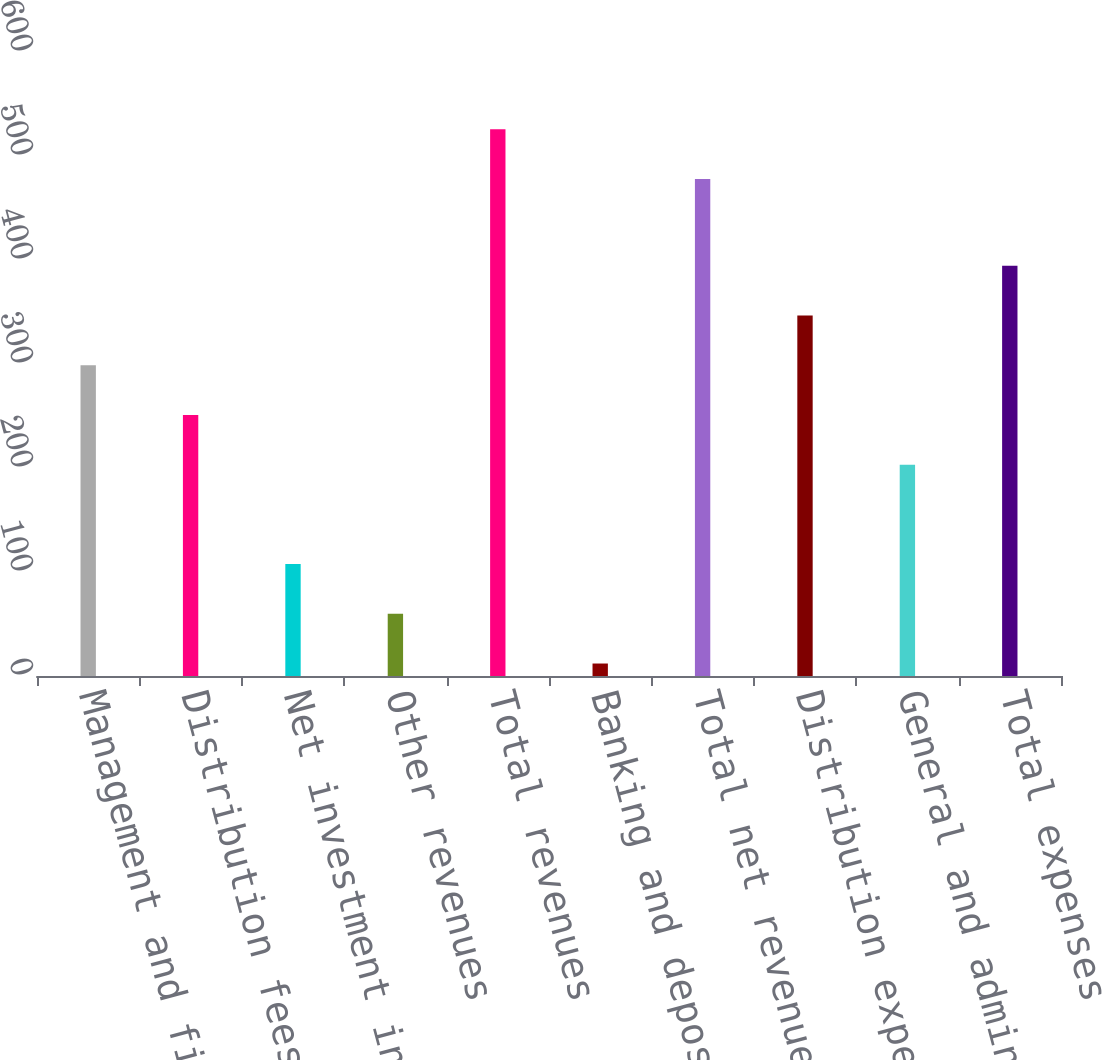<chart> <loc_0><loc_0><loc_500><loc_500><bar_chart><fcel>Management and financial<fcel>Distribution fees<fcel>Net investment income<fcel>Other revenues<fcel>Total revenues<fcel>Banking and deposit interest<fcel>Total net revenues<fcel>Distribution expenses<fcel>General and administrative<fcel>Total expenses<nl><fcel>298.8<fcel>251<fcel>107.6<fcel>59.8<fcel>525.8<fcel>12<fcel>478<fcel>346.6<fcel>203.2<fcel>394.4<nl></chart> 